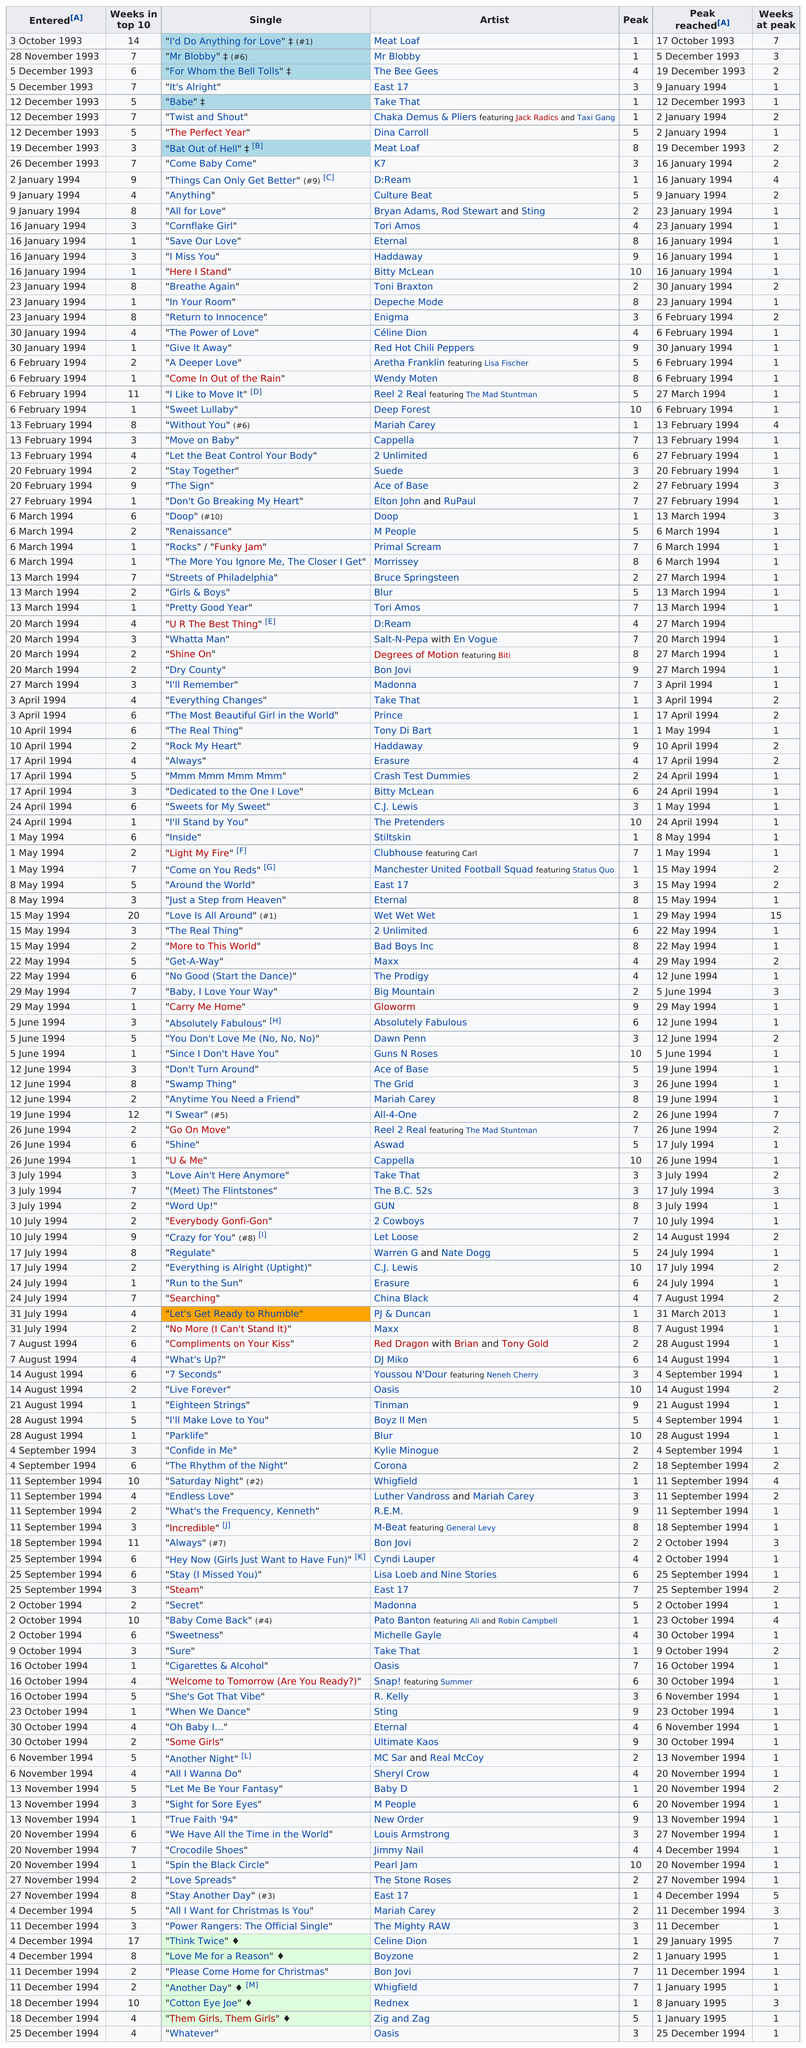Highlight a few significant elements in this photo. The song "Think Twice," released by Celine Dion in 1994, spent 17 weeks on the UK Singles Chart, making it one of her most successful releases in the country. What is the first entered date?" the man asked. "It is 3 October 1993," the woman replied. The song "I'd Do Anything for Love" by the artist listed, which had four weeks at peak, is the first song listed. The single 'Come Baby Come' was the last one to be on the charts in 1993. The artist who has only one of their songs entered on January 2, 1994 is D:Ream. 